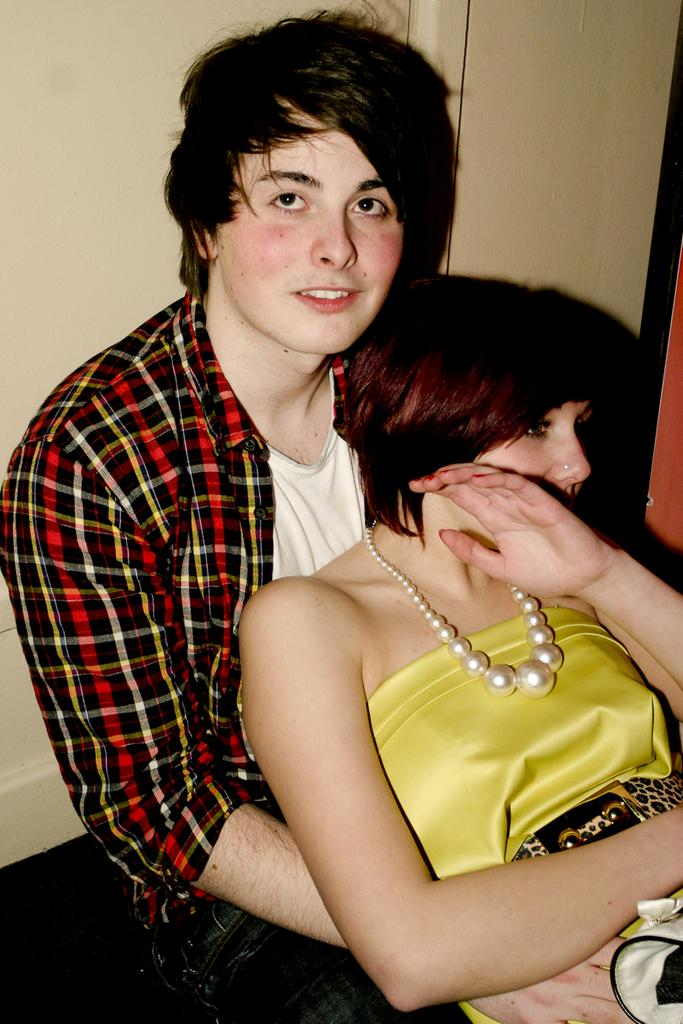How many people are present in the image? There are two members in the image. What is the position of one of the members in the image? One of the members is sitting on the floor. Can you describe the genders of the people in the image? There is a man and a woman in the image. What can be seen in the background of the image? There is a wall in the background of the image. What type of goat can be seen in the image? There is no goat present in the image. How does the zephyr affect the woman's hair in the image? There is no mention of a zephyr or any wind in the image, so it cannot be determined how it would affect the woman's hair. 